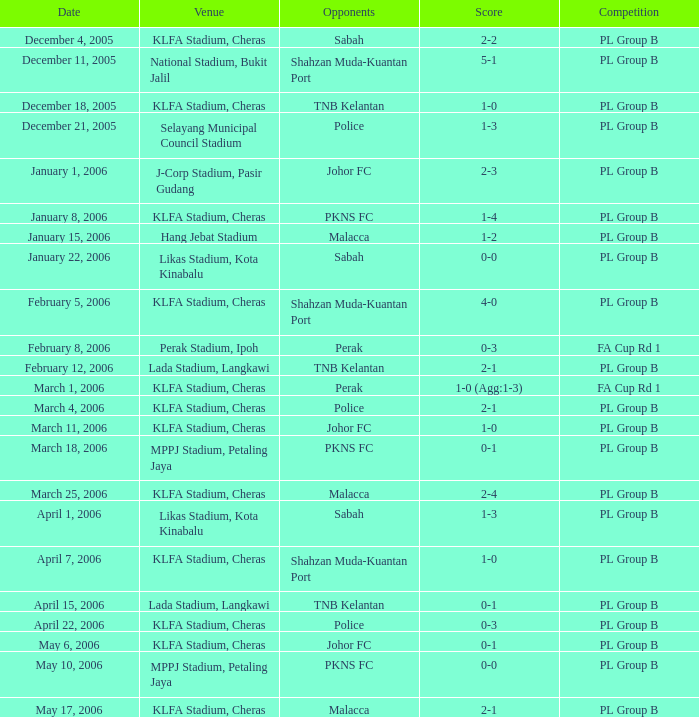In which contest does the score stand at 0-1, with pkns fc as the opponent? PL Group B. 